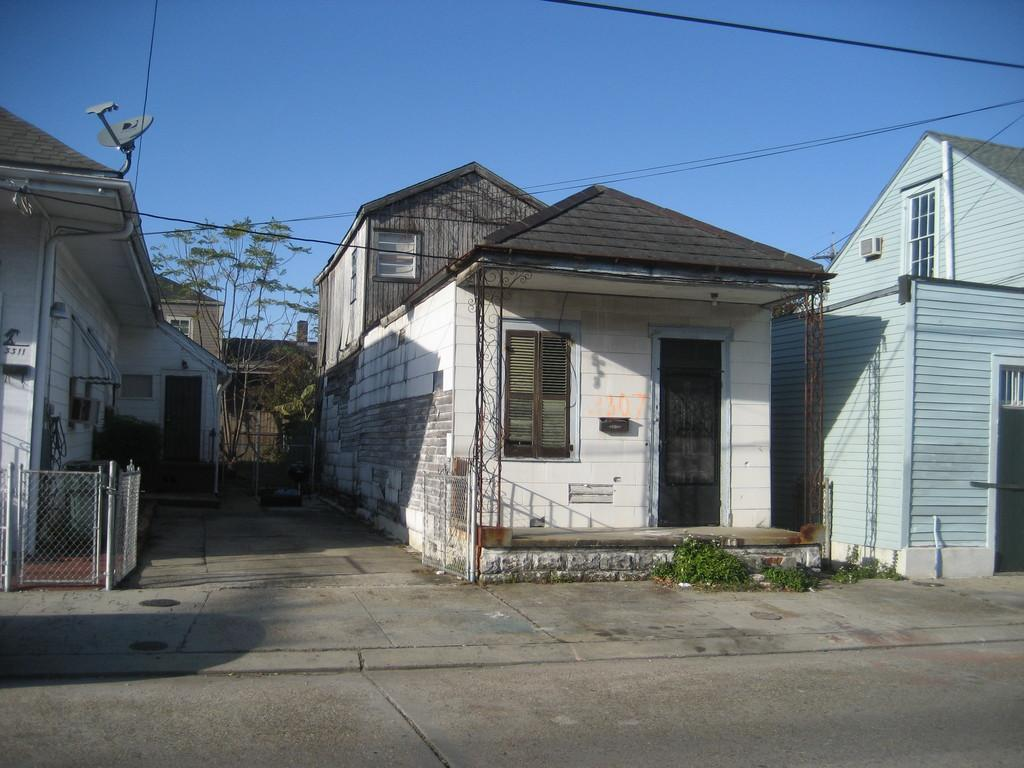What is the main feature of the image? There is a road in the image. What can be seen beside the road? There are buildings beside the road. What type of vegetation is present in the image? There are trees and grass in the image. What type of structure is visible in the image? There is an antenna visible in the image. What else can be seen in the image? There are wires in the image. What is visible in the background of the image? The sky is visible in the background of the image. How many letters are being held by the cats in the image? There are no cats present in the image, so it is not possible to determine how many letters they might be holding. 